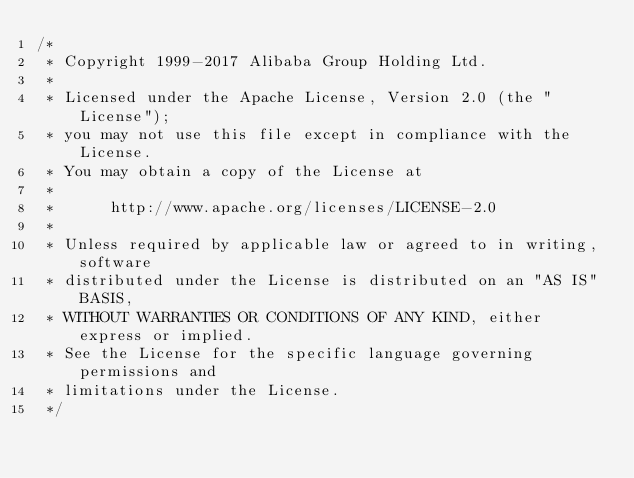<code> <loc_0><loc_0><loc_500><loc_500><_Java_>/*
 * Copyright 1999-2017 Alibaba Group Holding Ltd.
 *
 * Licensed under the Apache License, Version 2.0 (the "License");
 * you may not use this file except in compliance with the License.
 * You may obtain a copy of the License at
 *
 *      http://www.apache.org/licenses/LICENSE-2.0
 *
 * Unless required by applicable law or agreed to in writing, software
 * distributed under the License is distributed on an "AS IS" BASIS,
 * WITHOUT WARRANTIES OR CONDITIONS OF ANY KIND, either express or implied.
 * See the License for the specific language governing permissions and
 * limitations under the License.
 */</code> 